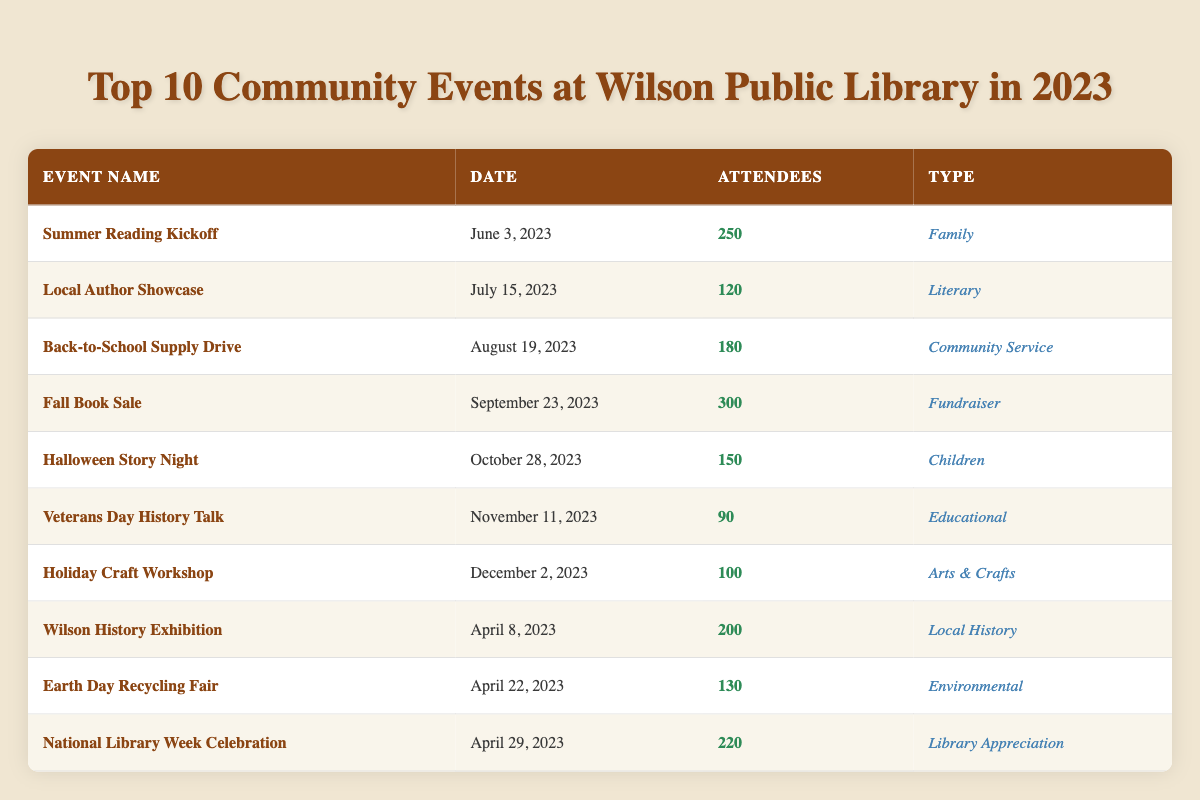What event had the highest number of attendees? The "Fall Book Sale" had the highest number of attendees at 300. This can be determined by looking through the "Attendees" column and identifying the maximum value.
Answer: Fall Book Sale On what date was the "Earth Day Recycling Fair" held? The table shows that the "Earth Day Recycling Fair" took place on April 22, 2023, according to the "Date" column next to this event's name.
Answer: April 22, 2023 How many attendees were there in total for the events in April? To find the total attendees for events held in April, we need to sum the attendees from "Wilson History Exhibition" (200), "Earth Day Recycling Fair" (130), and "National Library Week Celebration" (220), which gives us 200 + 130 + 220 = 550.
Answer: 550 Is there an event focused on educational purposes? Yes, the "Veterans Day History Talk" is an educational event as indicated in the "Type" column next to this event's name.
Answer: Yes Which event had fewer attendees than 150? The event with fewer than 150 attendees was the "Veterans Day History Talk" with 90 attendees. By checking the "Attendees" column, one can easily spot that this value is below 150.
Answer: Veterans Day History Talk What was the average number of attendees in community service events? The community service event is only "Back-to-School Supply Drive" with 180 attendees. Since there's only one event, the average is simply 180/1 = 180.
Answer: 180 Which type of event had the most total attendees? We sum the attendees for each event type. Family (250), Literary (120), Community Service (180), Fundraiser (300), Children (150), Educational (90), Arts & Crafts (100), Local History (200), Environmental (130), Library Appreciation (220). The total for the Fundraiser type is highest at 300.
Answer: Fundraiser Was there any event that took place in October? Yes, the "Halloween Story Night" is the event that took place in October, as listed in the "Date" column of the table.
Answer: Yes 